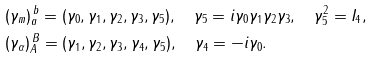Convert formula to latex. <formula><loc_0><loc_0><loc_500><loc_500>& ( \gamma _ { m } ) _ { a } ^ { \, b } = ( \gamma _ { 0 } , \gamma _ { 1 } , \gamma _ { 2 } , \gamma _ { 3 } , \gamma _ { 5 } ) , \quad \gamma _ { 5 } = i \gamma _ { 0 } \gamma _ { 1 } \gamma _ { 2 } \gamma _ { 3 } , \quad \gamma _ { 5 } ^ { 2 } = I _ { 4 } , \\ & ( \gamma _ { \alpha } ) _ { A } ^ { \, B } = ( \gamma _ { 1 } , \gamma _ { 2 } , \gamma _ { 3 } , \gamma _ { 4 } , \gamma _ { 5 } ) , \quad \gamma _ { 4 } = - i \gamma _ { 0 } .</formula> 